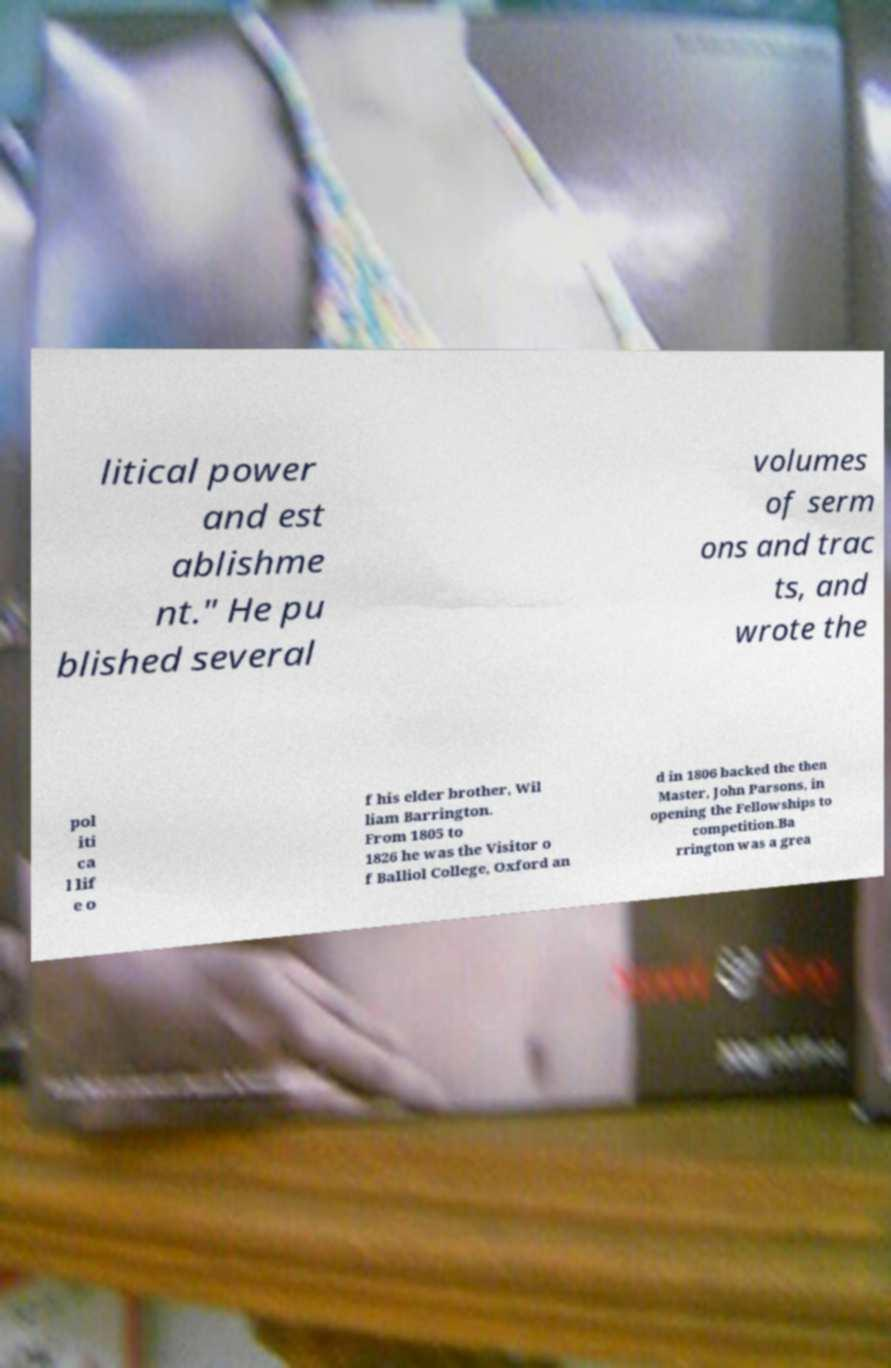Could you extract and type out the text from this image? litical power and est ablishme nt." He pu blished several volumes of serm ons and trac ts, and wrote the pol iti ca l lif e o f his elder brother, Wil liam Barrington. From 1805 to 1826 he was the Visitor o f Balliol College, Oxford an d in 1806 backed the then Master, John Parsons, in opening the Fellowships to competition.Ba rrington was a grea 